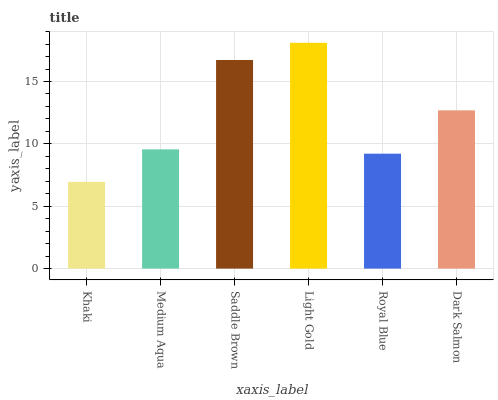Is Medium Aqua the minimum?
Answer yes or no. No. Is Medium Aqua the maximum?
Answer yes or no. No. Is Medium Aqua greater than Khaki?
Answer yes or no. Yes. Is Khaki less than Medium Aqua?
Answer yes or no. Yes. Is Khaki greater than Medium Aqua?
Answer yes or no. No. Is Medium Aqua less than Khaki?
Answer yes or no. No. Is Dark Salmon the high median?
Answer yes or no. Yes. Is Medium Aqua the low median?
Answer yes or no. Yes. Is Royal Blue the high median?
Answer yes or no. No. Is Saddle Brown the low median?
Answer yes or no. No. 